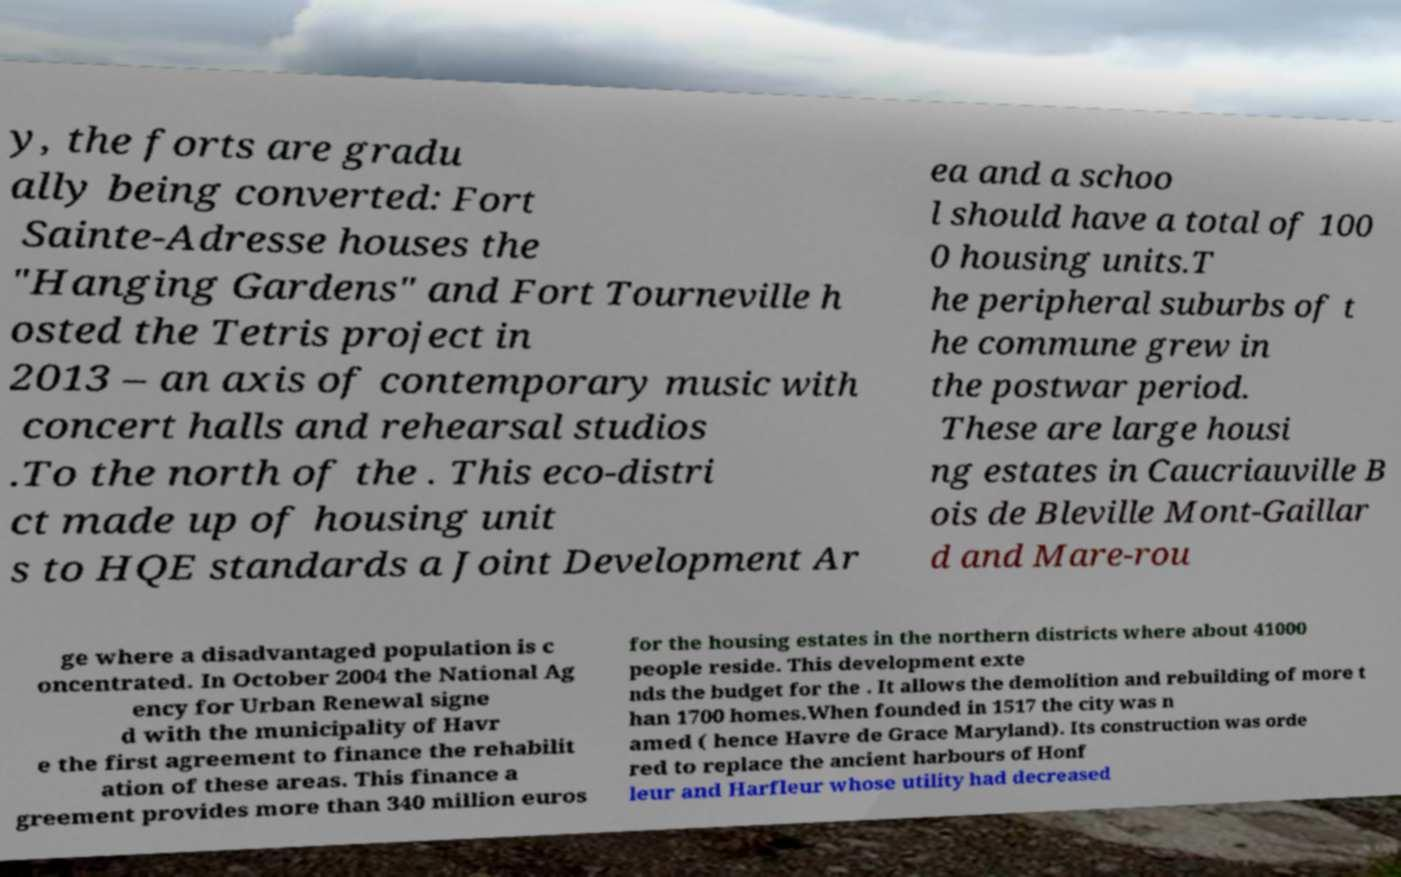Can you read and provide the text displayed in the image?This photo seems to have some interesting text. Can you extract and type it out for me? y, the forts are gradu ally being converted: Fort Sainte-Adresse houses the "Hanging Gardens" and Fort Tourneville h osted the Tetris project in 2013 – an axis of contemporary music with concert halls and rehearsal studios .To the north of the . This eco-distri ct made up of housing unit s to HQE standards a Joint Development Ar ea and a schoo l should have a total of 100 0 housing units.T he peripheral suburbs of t he commune grew in the postwar period. These are large housi ng estates in Caucriauville B ois de Bleville Mont-Gaillar d and Mare-rou ge where a disadvantaged population is c oncentrated. In October 2004 the National Ag ency for Urban Renewal signe d with the municipality of Havr e the first agreement to finance the rehabilit ation of these areas. This finance a greement provides more than 340 million euros for the housing estates in the northern districts where about 41000 people reside. This development exte nds the budget for the . It allows the demolition and rebuilding of more t han 1700 homes.When founded in 1517 the city was n amed ( hence Havre de Grace Maryland). Its construction was orde red to replace the ancient harbours of Honf leur and Harfleur whose utility had decreased 